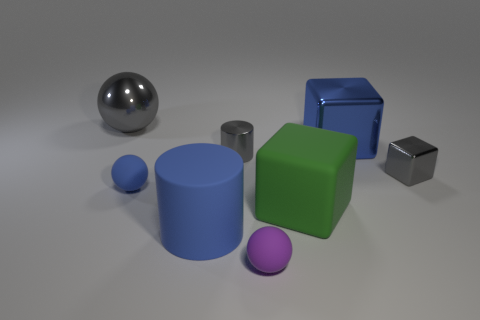Add 2 small gray blocks. How many objects exist? 10 Subtract all cylinders. How many objects are left? 6 Subtract 0 yellow blocks. How many objects are left? 8 Subtract all tiny purple objects. Subtract all big metal blocks. How many objects are left? 6 Add 8 tiny gray shiny things. How many tiny gray shiny things are left? 10 Add 4 large blue metal objects. How many large blue metal objects exist? 5 